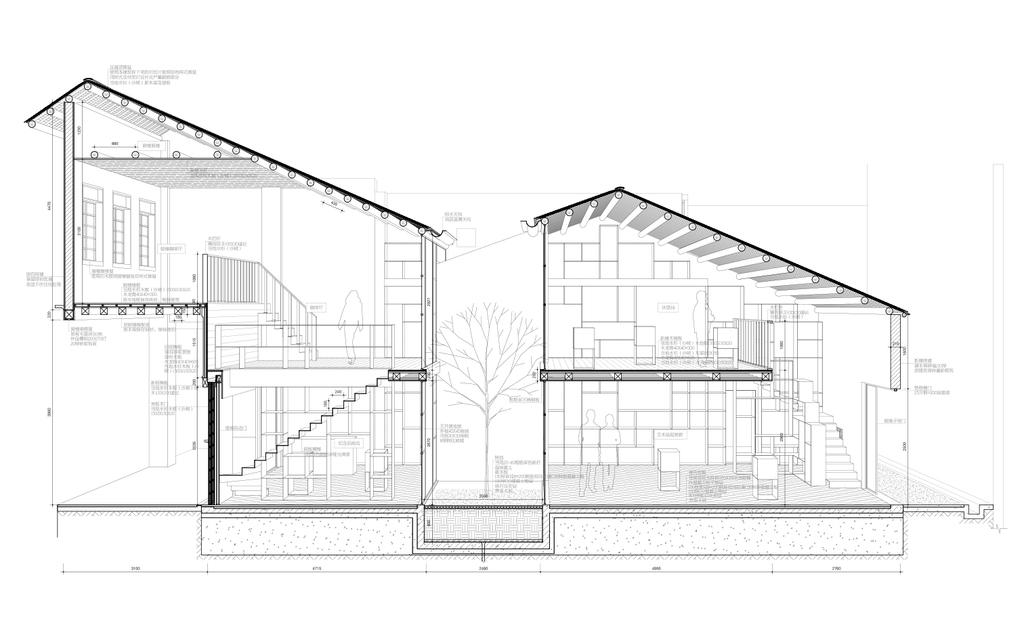What is the main subject of the drawing? The main subject of the drawing is a house. Can you describe the central element in the drawing? There is a building in the center of the drawing. What other object is located in the center of the drawing? There is a plant in the center of the drawing. Are there any words or letters in the drawing? Yes, there is some text in the drawing. What type of cabbage is growing next to the house in the drawing? There is no cabbage present in the drawing; it features a plant, but no specific type of vegetable is mentioned or depicted. 